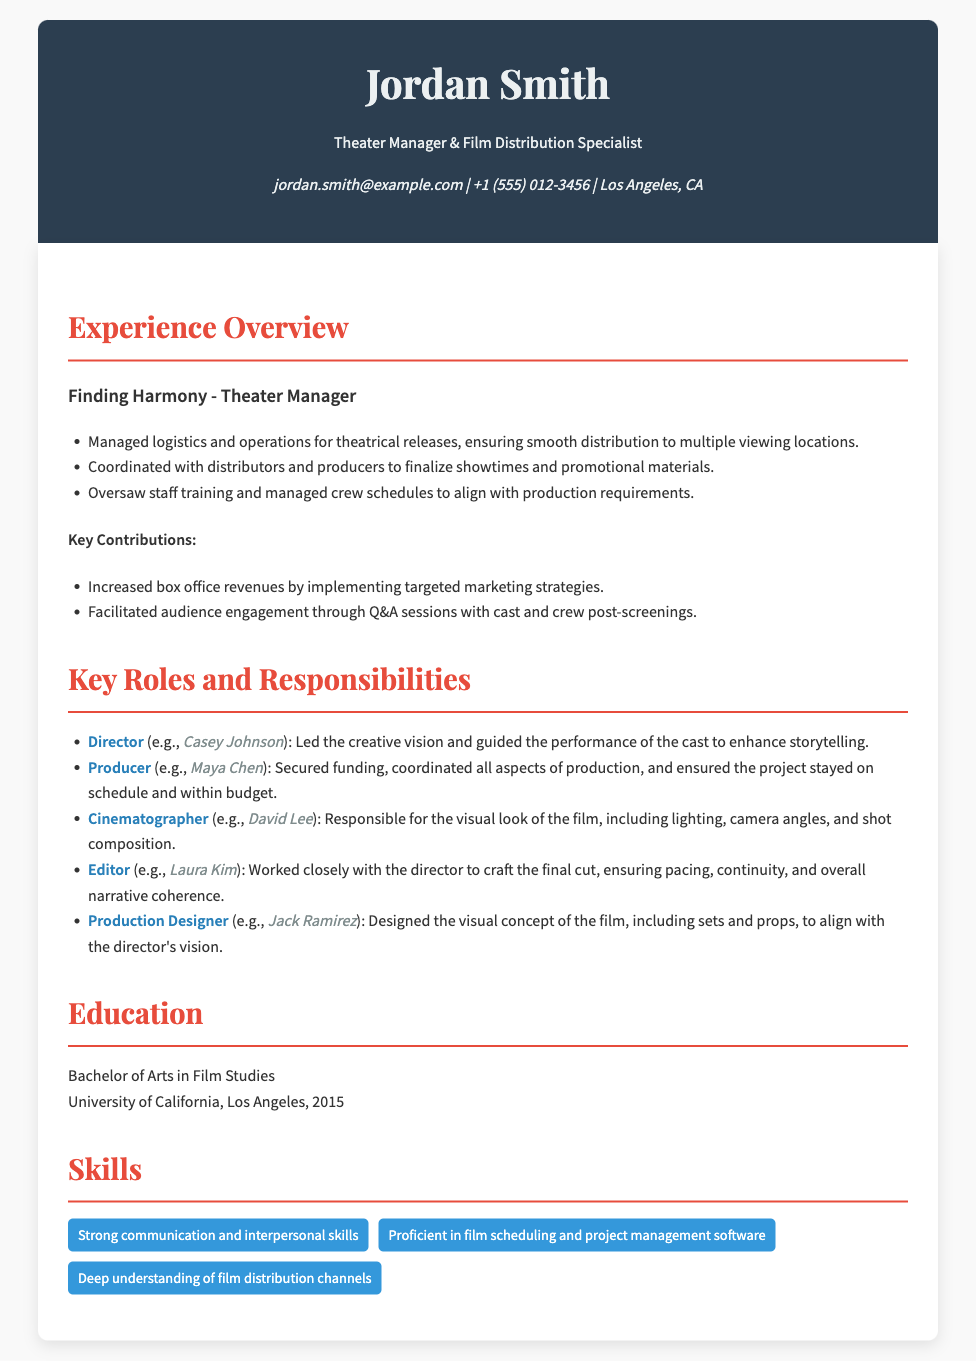what is the name of the theater manager? The document states the name of the theater manager is Jordan Smith.
Answer: Jordan Smith what is the primary role of Jordan Smith? The document describes Jordan Smith as a Theater Manager & Film Distribution Specialist.
Answer: Theater Manager & Film Distribution Specialist which production did Jordan Smith work on? The document mentions the production called Finding Harmony.
Answer: Finding Harmony what year did Jordan Smith graduate? The document indicates Jordan Smith graduated in 2015.
Answer: 2015 who was the director mentioned in the roles and responsibilities? The document lists Casey Johnson as the director.
Answer: Casey Johnson what key contribution did Jordan Smith make to box office revenues? The document states that Jordan Smith increased box office revenues by implementing targeted marketing strategies.
Answer: targeted marketing strategies which skill is associated with film scheduling? The document indicates proficiency in film scheduling and project management software as a skill.
Answer: film scheduling and project management software how many key roles are listed in the document? The document provides a list of five key roles and responsibilities.
Answer: five who is the production designer mentioned in the document? The document states that Jack Ramirez is the production designer.
Answer: Jack Ramirez what is the main focus of the Experience Overview section? The document's Experience Overview focuses on Jordan Smith's roles, responsibilities, and contributions in theatrical releases.
Answer: roles, responsibilities, and contributions in theatrical releases 